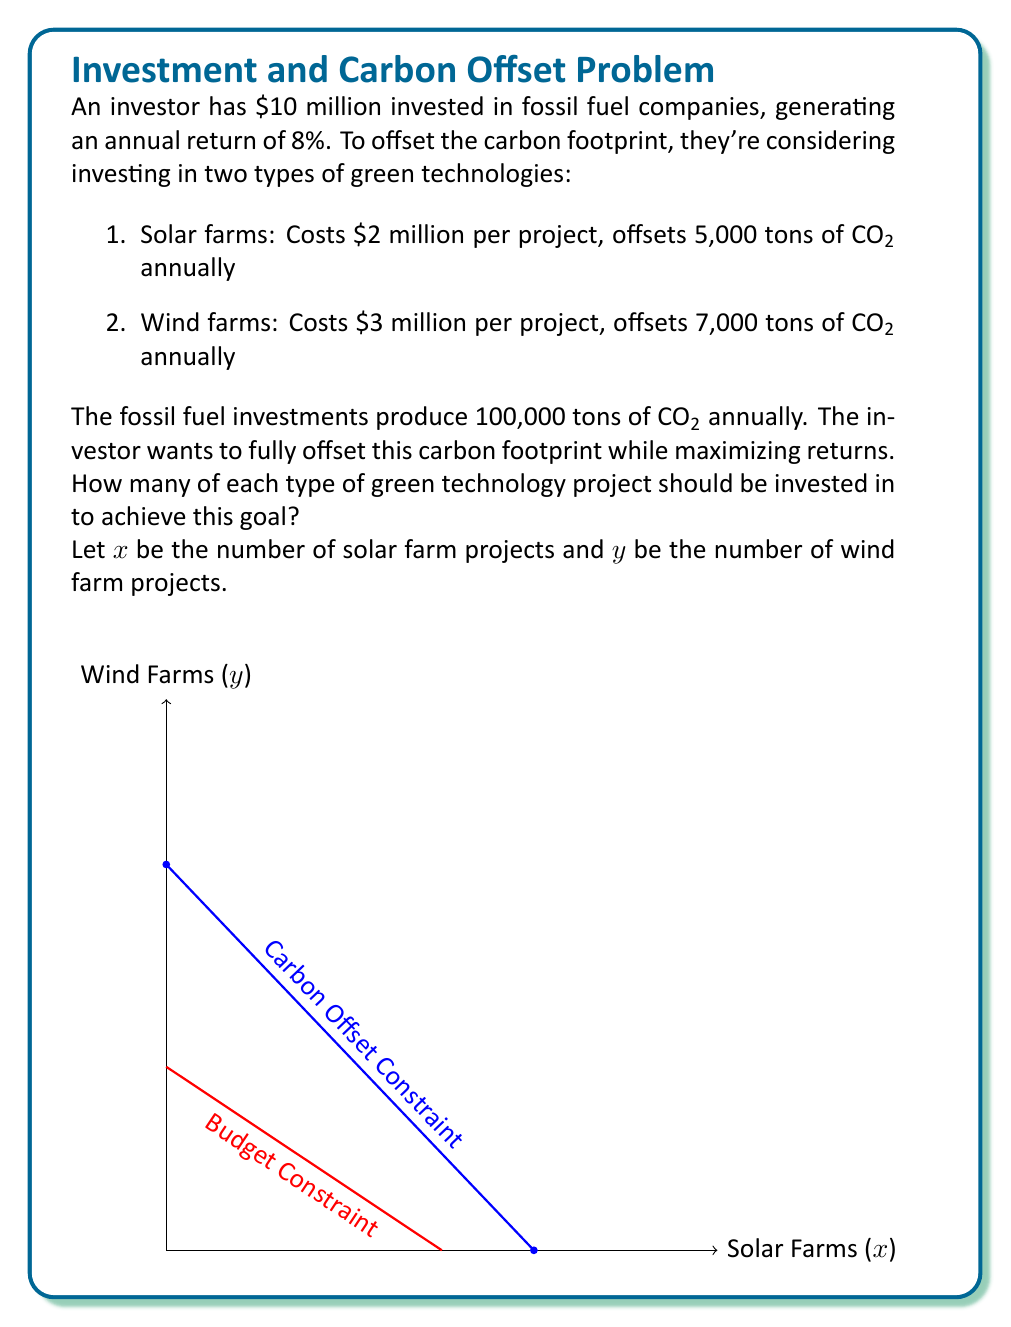Solve this math problem. Let's approach this step-by-step:

1) First, we need to set up our constraints:

   Carbon offset constraint: $5000x + 7000y \geq 100000$
   Budget constraint: $2x + 3y \leq 10$

2) We want to maximize the remaining funds for the fossil fuel investment. So our objective function is:

   $\text{Maximize } Z = 10 - (2x + 3y)$

3) We can simplify our constraints:

   $5x + 7y \geq 100$ (dividing everything by 1000)
   $2x + 3y \leq 10$

4) We can solve this using the graphical method. The feasible region is the area that satisfies both constraints.

5) The optimal solution will be at one of the corner points of this feasible region. We need to find the intersection of these lines:

   $5x + 7y = 100$
   $2x + 3y = 10$

6) Solving these equations:
   
   Multiply the second equation by 5/2: $5x + 7.5y = 25$
   Subtract from the first equation: $-0.5y = 75$
   $y = 15$
   
   Substituting back: $5x + 7(15) = 100$
   $5x = 100 - 105 = -5$
   $x = -1$

7) Since we can't have negative projects, this point is not in our feasible region. Therefore, the optimal solution must be at one of the axis intersections of our constraints.

8) For the carbon offset constraint:
   If $x = 20$, $y = 0$
   If $y = 14.29$, $x = 0$

9) For the budget constraint:
   If $x = 5$, $y = 0$
   If $y = 3.33$, $x = 0$

10) The feasible integer solutions are:
    $(x,y) = (5,0)$ or $(0,3)$

11) Evaluating our objective function:
    For $(5,0)$: $Z = 10 - (2(5) + 3(0)) = 0$
    For $(0,3)$: $Z = 10 - (2(0) + 3(3)) = 1$

Therefore, the optimal solution is to invest in 3 wind farm projects.
Answer: 3 wind farm projects 